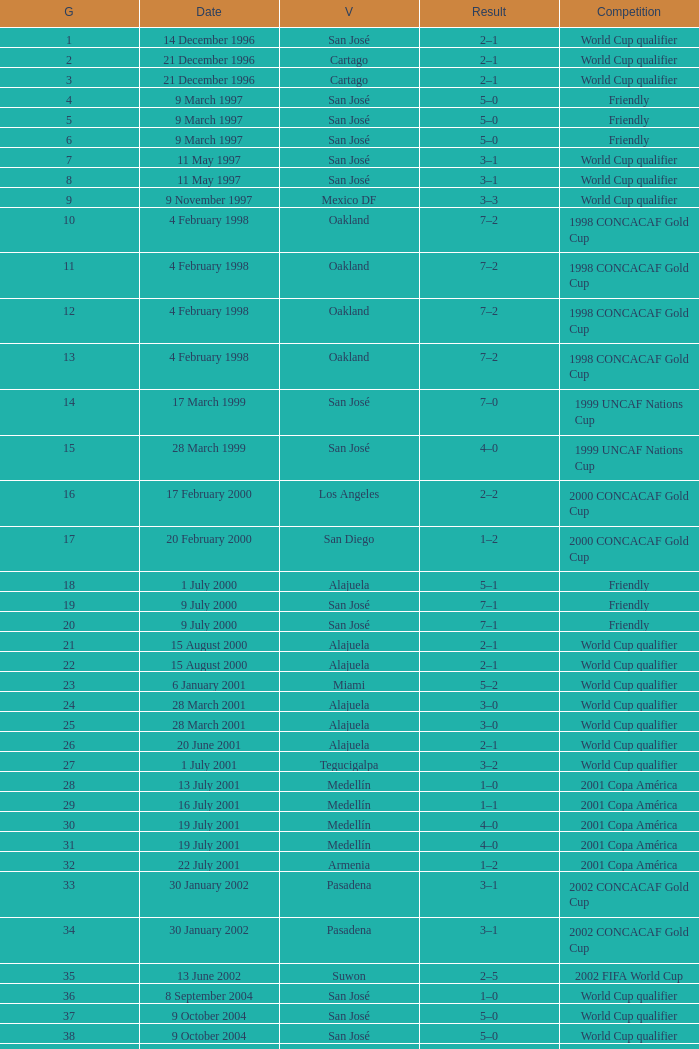What is the result in oakland? 7–2, 7–2, 7–2, 7–2. 